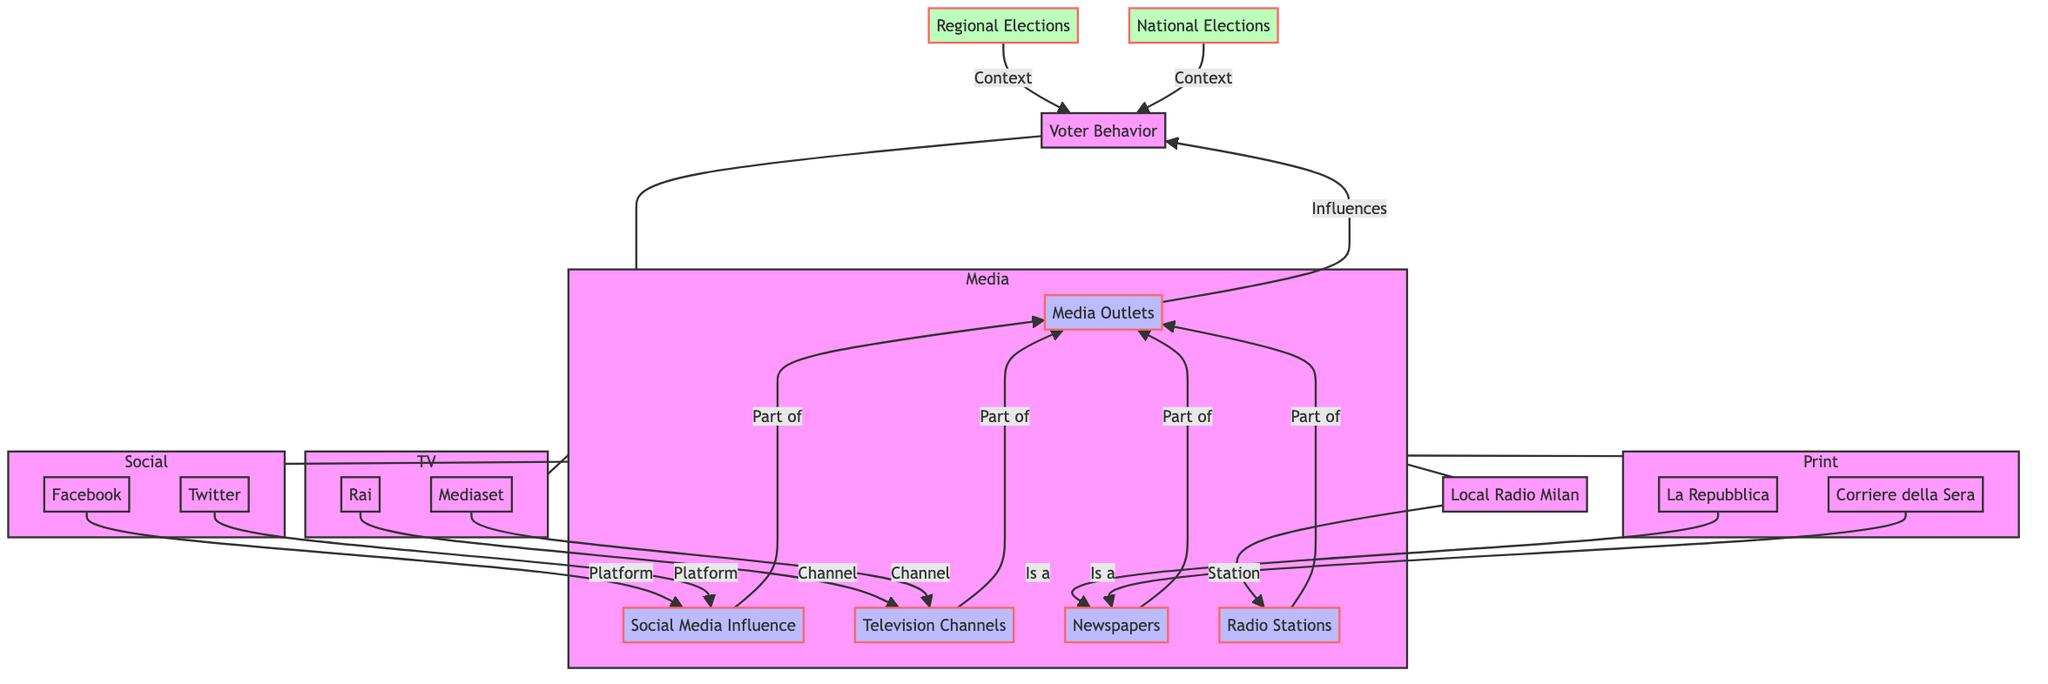What is the primary factor represented in the diagram that influences voter behavior? The diagram indicates that media outlets are the primary factor influencing voter behavior, as the relationship shows "Influences" from the media outlets node to the voter behavior node.
Answer: Media Outlets How many types of media are represented in the diagram? There are three distinct types of media represented: social media, television channels, and newspapers (alongside radio stations). This makes a total of four unique categories.
Answer: Four Which newspaper is identified as a part of the media outlets? The diagram identifies "La Repubblica" as a specific newspaper that is part of the media outlets influencing voter behavior.
Answer: La Repubblica What type of media does "Twitter" fall under in the diagram? "Twitter" is categorized as a platform under the social media influence node in the diagram.
Answer: Platform Which edge connects "Television Channels" to "Media Outlets"? The edge connecting "Television Channels" to "Media Outlets" is labeled "Part of", indicating that television channels are a subset of the broader media outlets.
Answer: Part of How many total nodes are there in the diagram? The total number of nodes is 15, which includes all the different entities identified in the diagram.
Answer: Fifteen What context does the diagram provide regarding voter behavior? The diagram indicates that both regional elections and national elections provide context for understanding voter behavior, creating a broader framework.
Answer: Context Which social media platforms are listed in the diagram? The diagram lists "Facebook" and "Twitter" as the social media platforms influencing voter behavior.
Answer: Facebook and Twitter What is the relationship between "Local Radio Milan" and "Radio Stations"? The relationship is indicated by the label "Station", which shows that Local Radio Milan is a type of radio station within the broader radio stations category.
Answer: Station Which television channel is connected to the "Media Outlets" through an edge? The television channel "Rai" is connected to the media outlets node, indicating its role in the media landscape affecting voter behavior.
Answer: Rai 